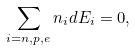<formula> <loc_0><loc_0><loc_500><loc_500>\sum _ { i = n , p , e } n _ { i } d E _ { i } = 0 ,</formula> 